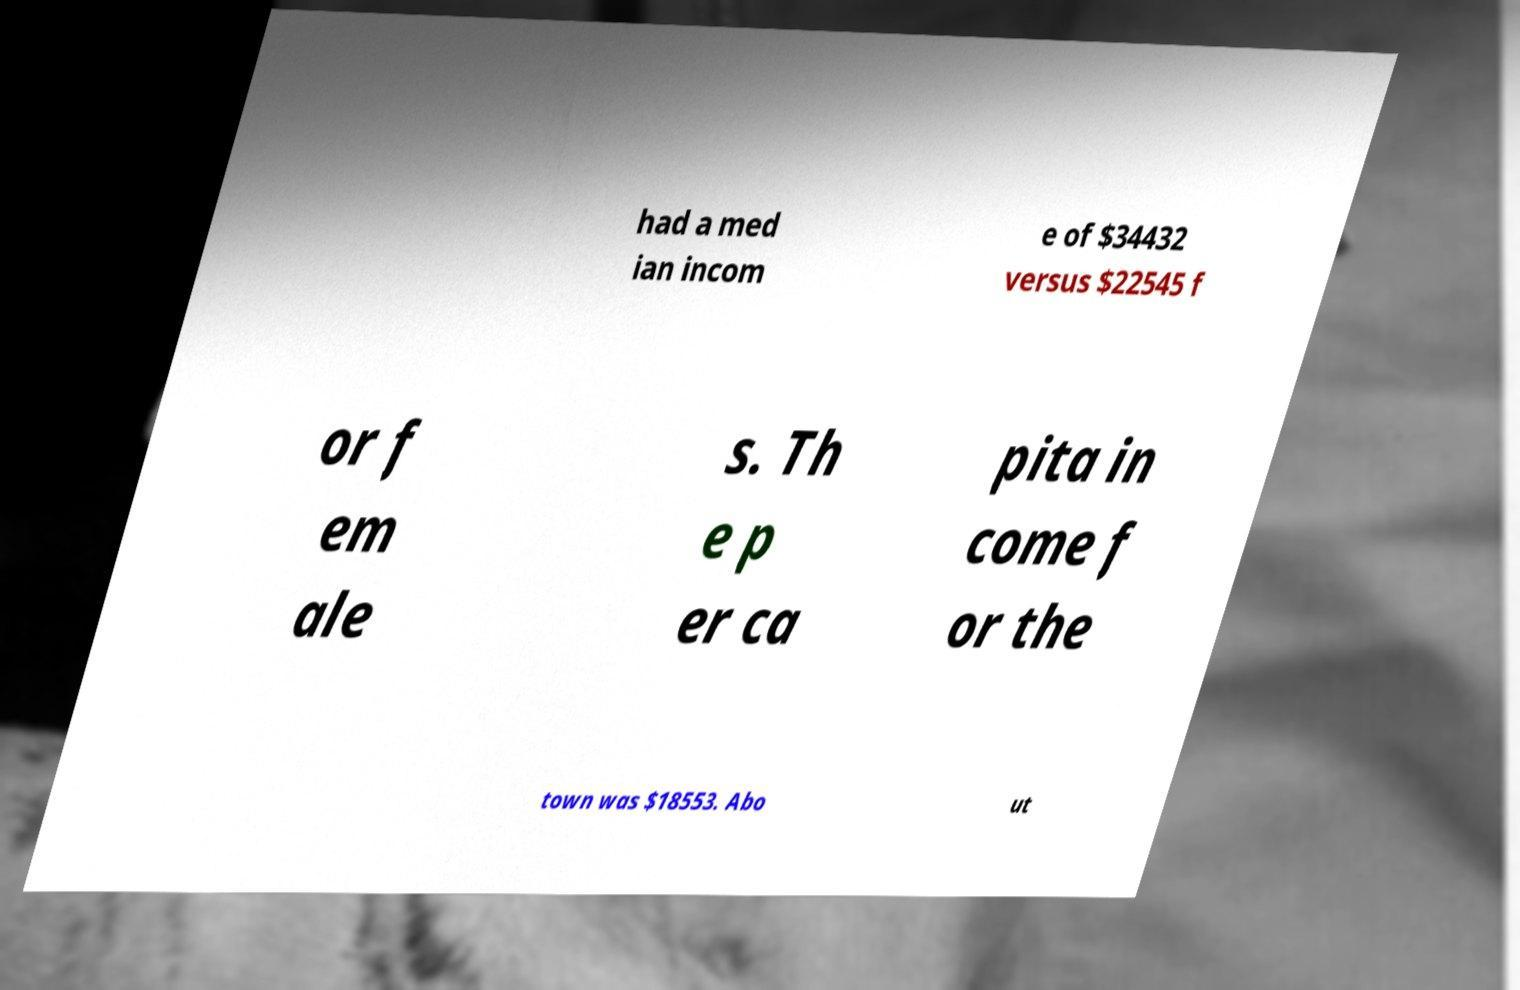I need the written content from this picture converted into text. Can you do that? had a med ian incom e of $34432 versus $22545 f or f em ale s. Th e p er ca pita in come f or the town was $18553. Abo ut 